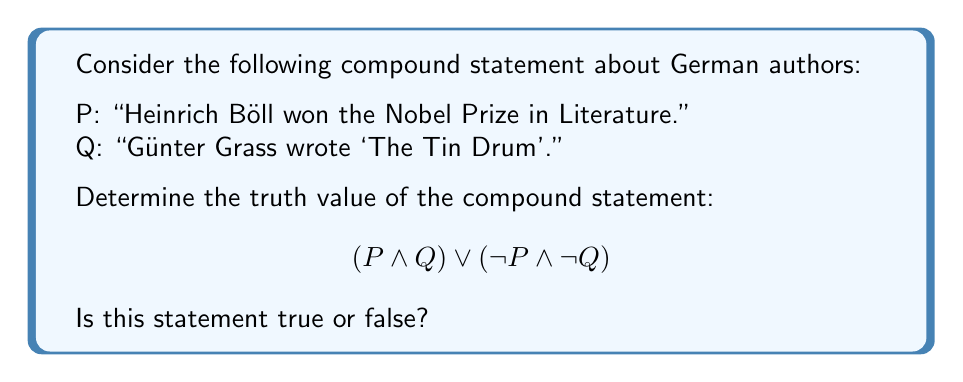What is the answer to this math problem? To determine the truth value of this compound statement, we need to break it down and evaluate each part:

1. First, let's establish the truth values of P and Q:
   P: "Heinrich Böll won the Nobel Prize in Literature" is true (He won in 1972).
   Q: "Günter Grass wrote 'The Tin Drum'" is true.

2. Now, let's evaluate each part of the compound statement:

   a) $(P \land Q)$:
      This is a conjunction (AND) of two true statements.
      True $\land$ True = True

   b) $(\neg P \land \neg Q)$:
      This is a conjunction of the negations of P and Q.
      $\neg P$ is false, and $\neg Q$ is false.
      False $\land$ False = False

3. The main connective in the compound statement is $\lor$ (OR):
   $$(P \land Q) \lor (\neg P \land \neg Q)$$
   We now have: True $\lor$ False

4. In propositional logic, the OR operation ($\lor$) returns true if at least one of its operands is true.

Therefore, since (P $\land$ Q) is true, the entire compound statement is true, regardless of the truth value of $(\neg P \land \neg Q)$.
Answer: True 